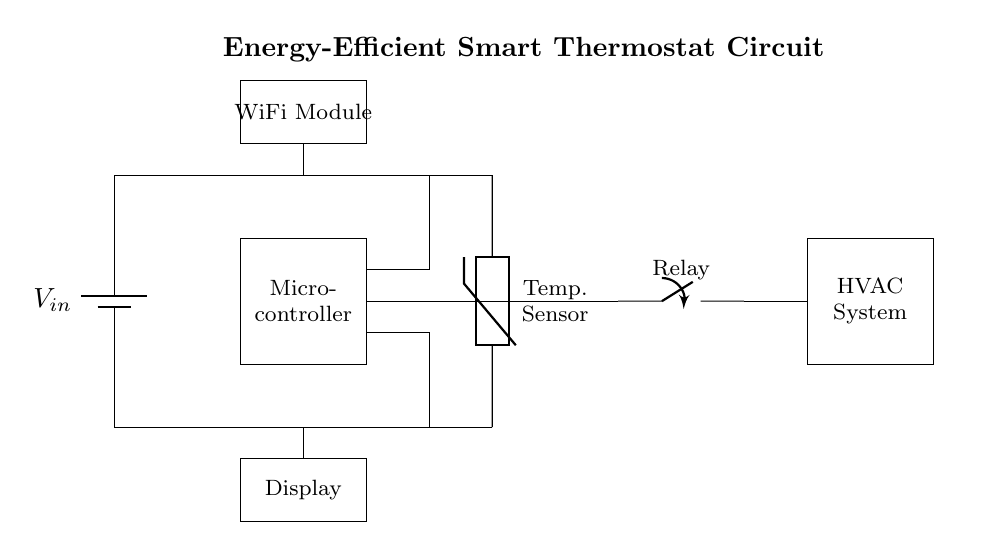What is the power supply voltage? The voltage supply is labeled as V_in in the circuit diagram, representing the input voltage, typical for many batteries.
Answer: V_in What type of sensor is used in the circuit? The component labeled as "Temp. Sensor" indicates that a thermistor is used, which is a type of temperature sensor sensitive to temperature changes.
Answer: Thermistor How does the microcontroller receive temperature data? The microcontroller, located in the circuit, has a direct connection to the temperature sensor, allowing it to receive data regarding current temperature which it can process.
Answer: Direct connection What component controls the HVAC system? The relay, depicted in the circuit, acts as a switch that is controlled by the microcontroller and can open or close to turn the HVAC system on or off.
Answer: Relay What is the function of the WiFi module? The WiFi module enables the thermostat to connect to a network for remote monitoring and control, allowing users to manage the thermostat from outside the home.
Answer: Network connection Which components are responsible for user interaction? The display component is utilized for user feedback and interaction, allowing users to view settings, temperature readings, or adjustments made on the thermostat.
Answer: Display What type of connection is used between the relay and HVAC system? The line connecting the relay to the HVAC system indicates a switching mechanism; they are directly connected, allowing the relay to control the power to the system.
Answer: Direct connection 